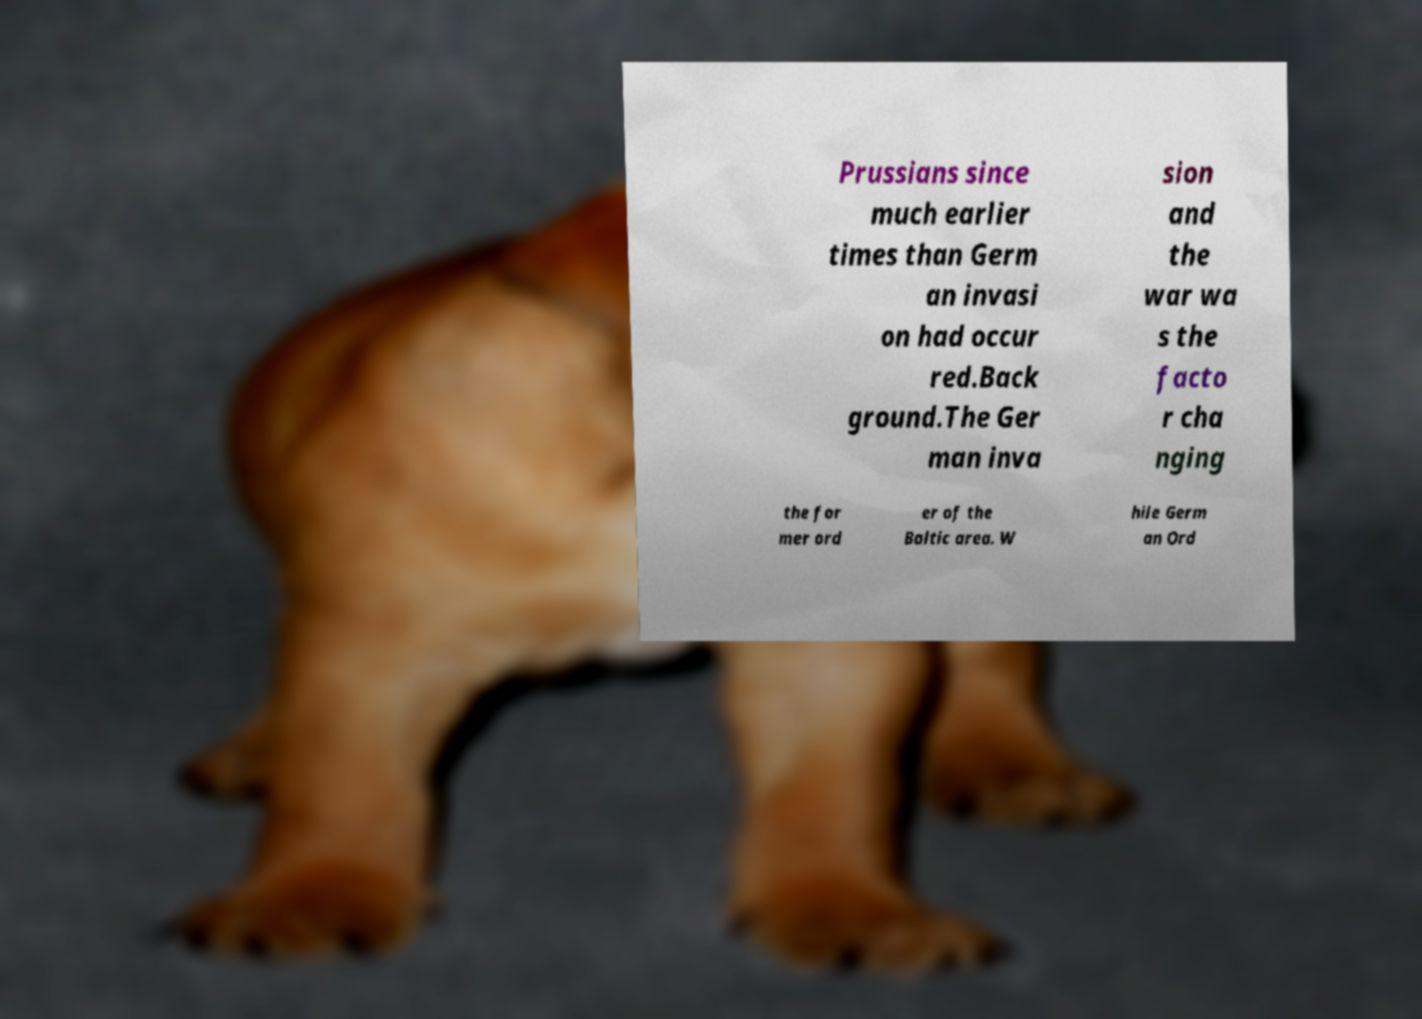Could you assist in decoding the text presented in this image and type it out clearly? Prussians since much earlier times than Germ an invasi on had occur red.Back ground.The Ger man inva sion and the war wa s the facto r cha nging the for mer ord er of the Baltic area. W hile Germ an Ord 